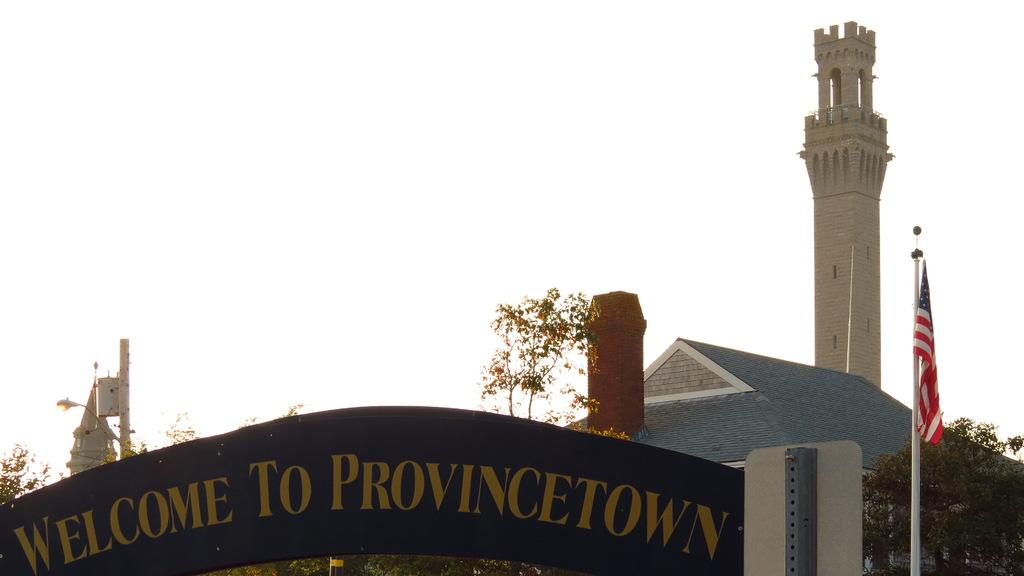What type of vegetation can be seen on the right side of the image? There are trees on the right side of the image. What structure is located on the right side of the image? There is a house on the right side of the image. What is attached to the pole on the right side of the image? There is a flag on the right side of the image. What object is present on the right side of the image for displaying information? There is a text board on the right side of the image. What type of vegetation can be seen on the left side of the image? There are trees on the left side of the image. What type of lighting is present on the left side of the image? There is a street light on the left side of the image. What type of structure is present on the left side of the image? There is a steeple on the left side of the image. What part of the natural environment is visible in the image? The sky is visible in the image. How much debt is the tiger carrying in the image? There is no tiger present in the image, and therefore no debt can be associated with it. What type of produce is being sold in the image? There is no produce being sold in the image. 